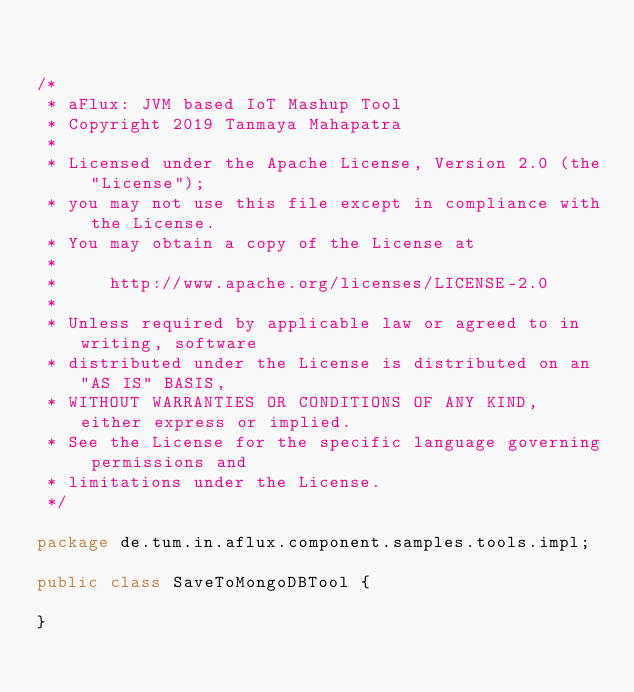Convert code to text. <code><loc_0><loc_0><loc_500><loc_500><_Java_>

/*
 * aFlux: JVM based IoT Mashup Tool
 * Copyright 2019 Tanmaya Mahapatra
 *
 * Licensed under the Apache License, Version 2.0 (the "License");
 * you may not use this file except in compliance with the License.
 * You may obtain a copy of the License at
 *
 *     http://www.apache.org/licenses/LICENSE-2.0
 *
 * Unless required by applicable law or agreed to in writing, software
 * distributed under the License is distributed on an "AS IS" BASIS,
 * WITHOUT WARRANTIES OR CONDITIONS OF ANY KIND, either express or implied.
 * See the License for the specific language governing permissions and
 * limitations under the License.
 */

package de.tum.in.aflux.component.samples.tools.impl;

public class SaveToMongoDBTool {

}
</code> 